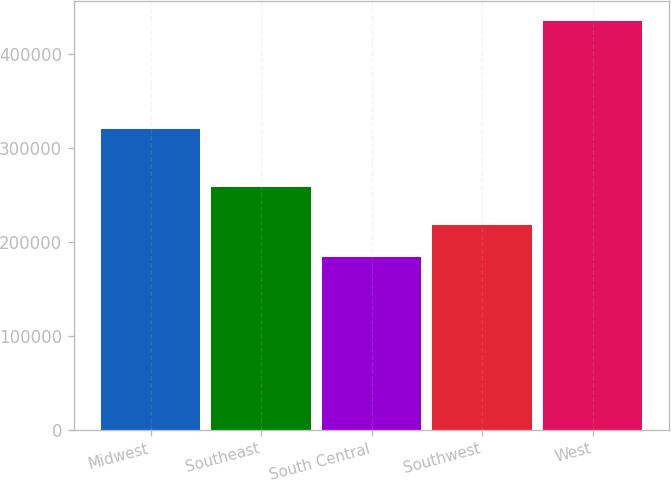Convert chart to OTSL. <chart><loc_0><loc_0><loc_500><loc_500><bar_chart><fcel>Midwest<fcel>Southeast<fcel>South Central<fcel>Southwest<fcel>West<nl><fcel>320200<fcel>258400<fcel>184300<fcel>218400<fcel>435400<nl></chart> 